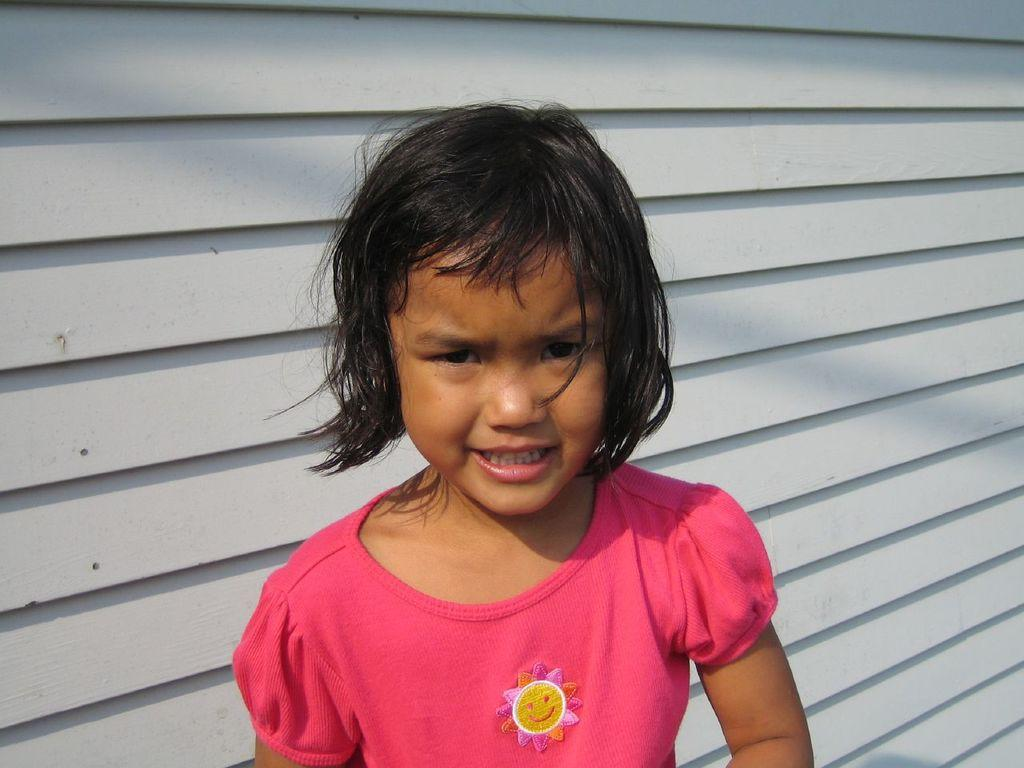What is present in the image? There is a person in the image. What can be seen in the background of the image? There is a wall in the background of the image. How many patches of powder are on the wall in the image? There is no mention of patches or powder in the image; it only features a person and a wall. 